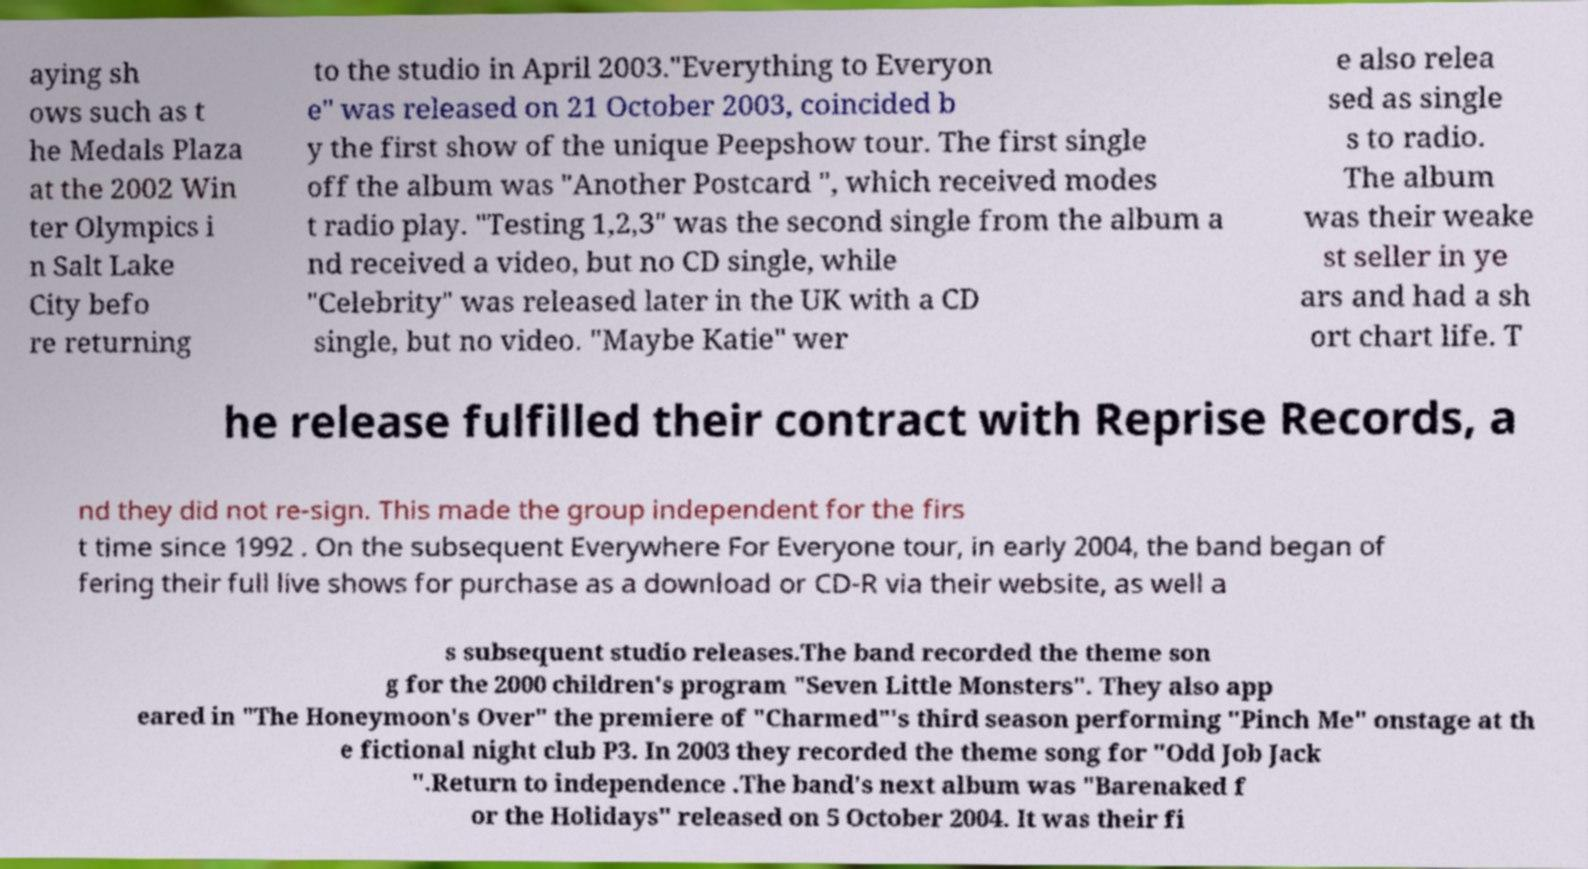Can you accurately transcribe the text from the provided image for me? aying sh ows such as t he Medals Plaza at the 2002 Win ter Olympics i n Salt Lake City befo re returning to the studio in April 2003."Everything to Everyon e" was released on 21 October 2003, coincided b y the first show of the unique Peepshow tour. The first single off the album was "Another Postcard ", which received modes t radio play. "Testing 1,2,3" was the second single from the album a nd received a video, but no CD single, while "Celebrity" was released later in the UK with a CD single, but no video. "Maybe Katie" wer e also relea sed as single s to radio. The album was their weake st seller in ye ars and had a sh ort chart life. T he release fulfilled their contract with Reprise Records, a nd they did not re-sign. This made the group independent for the firs t time since 1992 . On the subsequent Everywhere For Everyone tour, in early 2004, the band began of fering their full live shows for purchase as a download or CD-R via their website, as well a s subsequent studio releases.The band recorded the theme son g for the 2000 children's program "Seven Little Monsters". They also app eared in "The Honeymoon's Over" the premiere of "Charmed"'s third season performing "Pinch Me" onstage at th e fictional night club P3. In 2003 they recorded the theme song for "Odd Job Jack ".Return to independence .The band's next album was "Barenaked f or the Holidays" released on 5 October 2004. It was their fi 